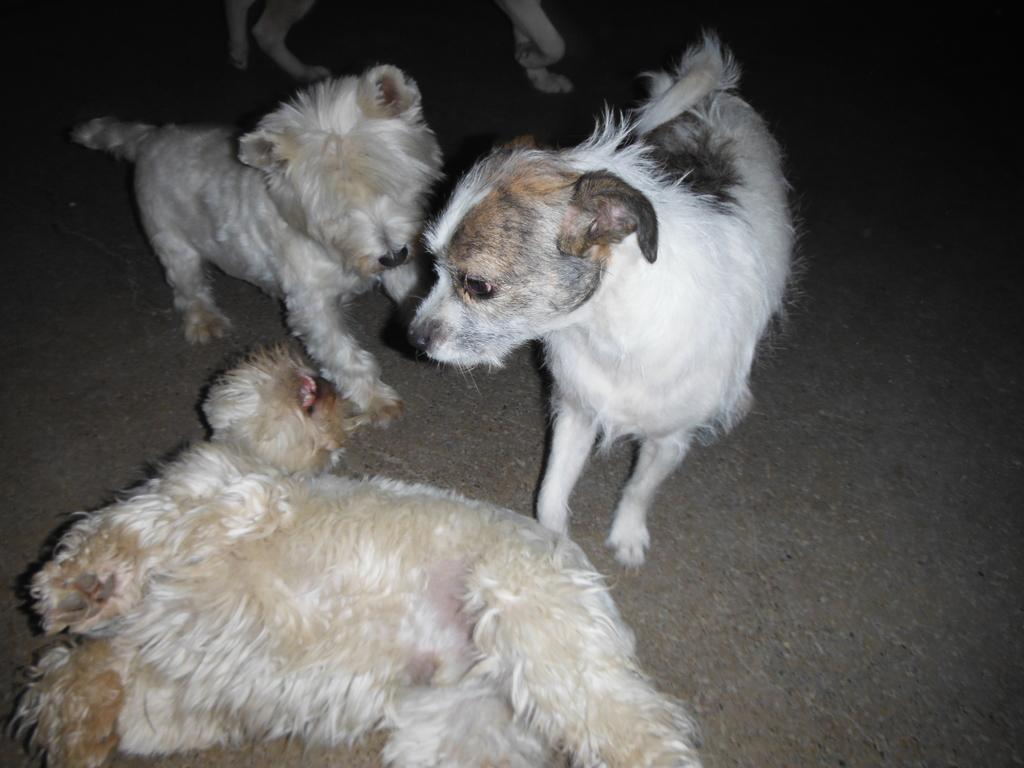What type of animals are present in the image? There are small puppies in the image. Can you describe the size of the puppies? The puppies are small in size. What might the puppies be doing in the image? The activity of the puppies cannot be determined from the image alone. What type of hearing aid is the puppy wearing in the image? There is no hearing aid present in the image, as puppies do not require or use hearing aids. 